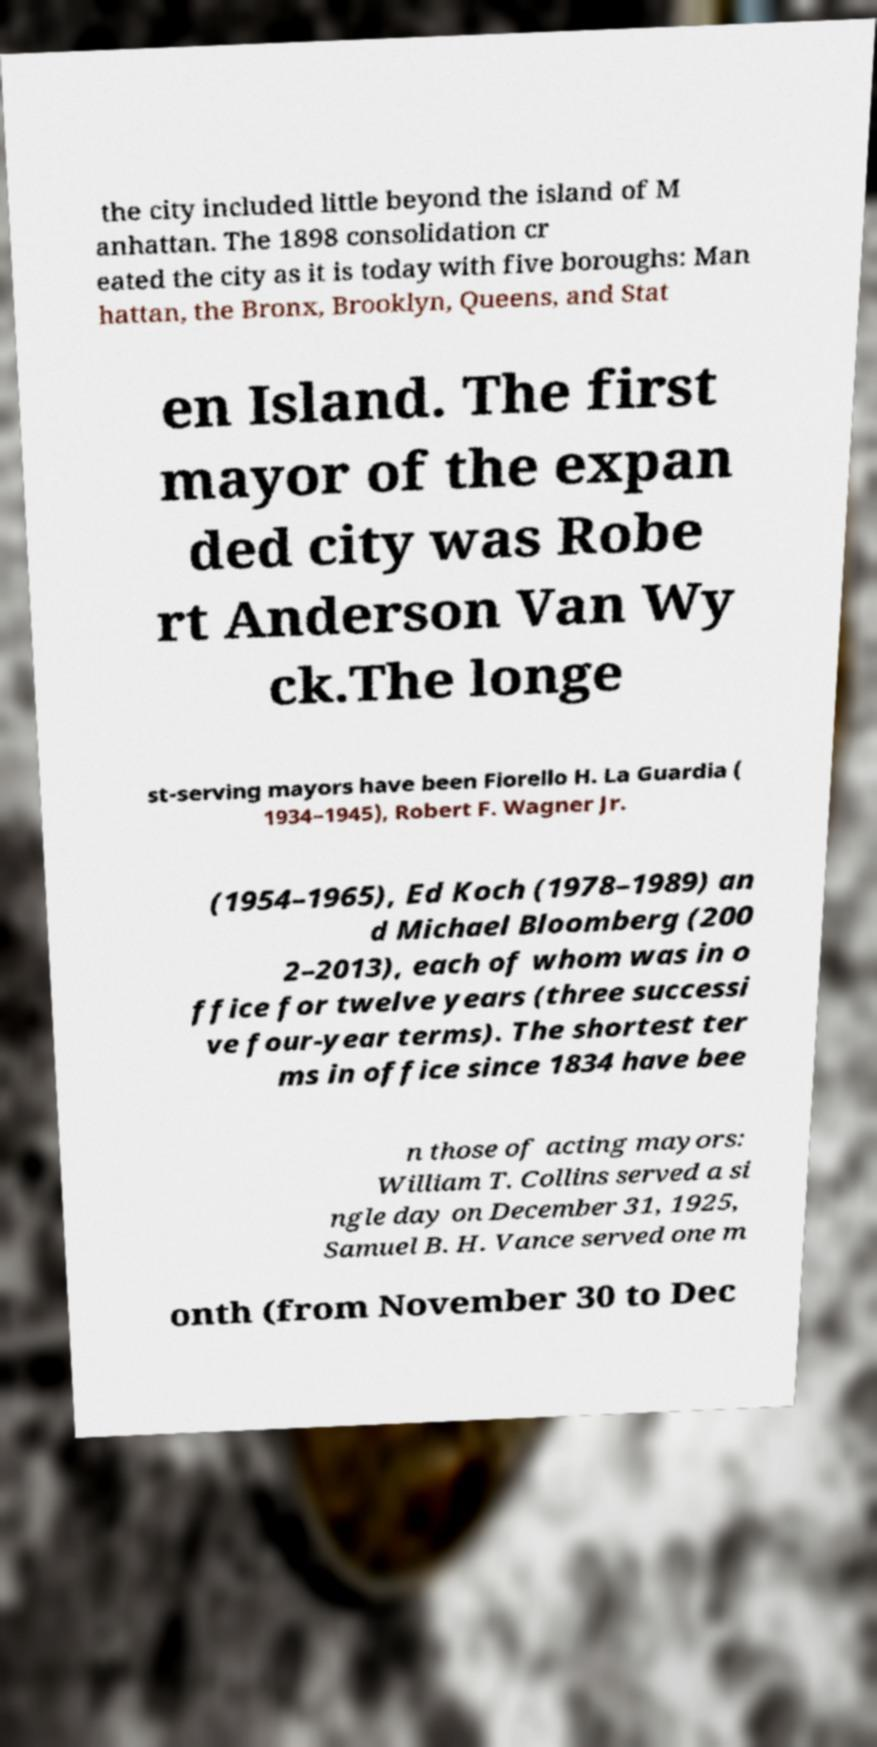There's text embedded in this image that I need extracted. Can you transcribe it verbatim? the city included little beyond the island of M anhattan. The 1898 consolidation cr eated the city as it is today with five boroughs: Man hattan, the Bronx, Brooklyn, Queens, and Stat en Island. The first mayor of the expan ded city was Robe rt Anderson Van Wy ck.The longe st-serving mayors have been Fiorello H. La Guardia ( 1934–1945), Robert F. Wagner Jr. (1954–1965), Ed Koch (1978–1989) an d Michael Bloomberg (200 2–2013), each of whom was in o ffice for twelve years (three successi ve four-year terms). The shortest ter ms in office since 1834 have bee n those of acting mayors: William T. Collins served a si ngle day on December 31, 1925, Samuel B. H. Vance served one m onth (from November 30 to Dec 